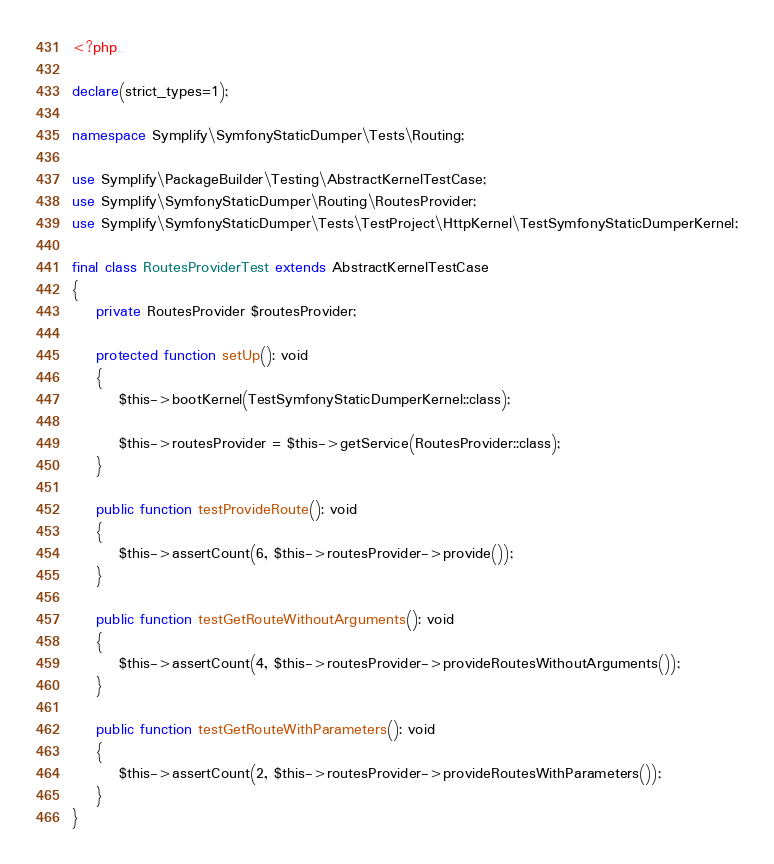Convert code to text. <code><loc_0><loc_0><loc_500><loc_500><_PHP_><?php

declare(strict_types=1);

namespace Symplify\SymfonyStaticDumper\Tests\Routing;

use Symplify\PackageBuilder\Testing\AbstractKernelTestCase;
use Symplify\SymfonyStaticDumper\Routing\RoutesProvider;
use Symplify\SymfonyStaticDumper\Tests\TestProject\HttpKernel\TestSymfonyStaticDumperKernel;

final class RoutesProviderTest extends AbstractKernelTestCase
{
    private RoutesProvider $routesProvider;

    protected function setUp(): void
    {
        $this->bootKernel(TestSymfonyStaticDumperKernel::class);

        $this->routesProvider = $this->getService(RoutesProvider::class);
    }

    public function testProvideRoute(): void
    {
        $this->assertCount(6, $this->routesProvider->provide());
    }

    public function testGetRouteWithoutArguments(): void
    {
        $this->assertCount(4, $this->routesProvider->provideRoutesWithoutArguments());
    }

    public function testGetRouteWithParameters(): void
    {
        $this->assertCount(2, $this->routesProvider->provideRoutesWithParameters());
    }
}
</code> 